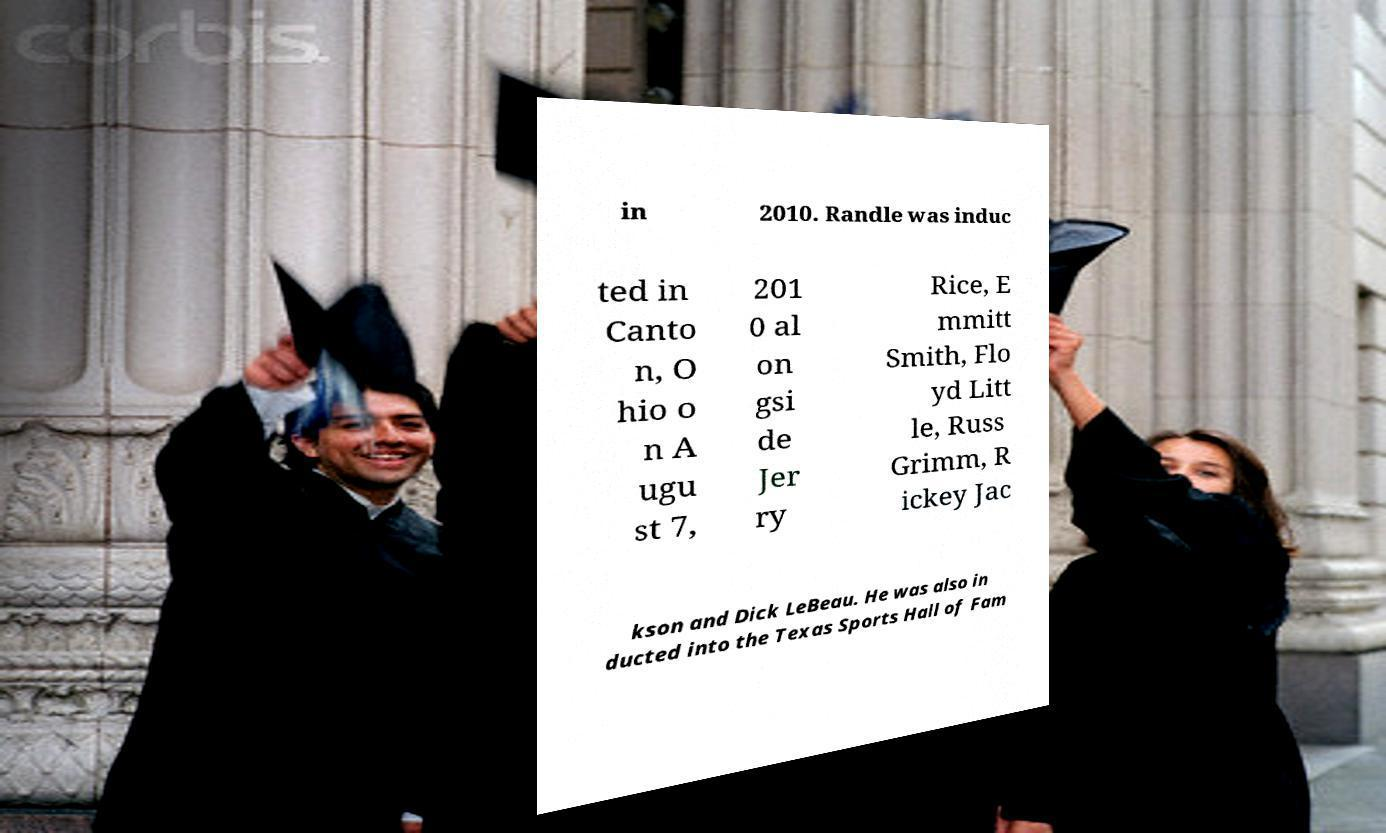Can you accurately transcribe the text from the provided image for me? in 2010. Randle was induc ted in Canto n, O hio o n A ugu st 7, 201 0 al on gsi de Jer ry Rice, E mmitt Smith, Flo yd Litt le, Russ Grimm, R ickey Jac kson and Dick LeBeau. He was also in ducted into the Texas Sports Hall of Fam 